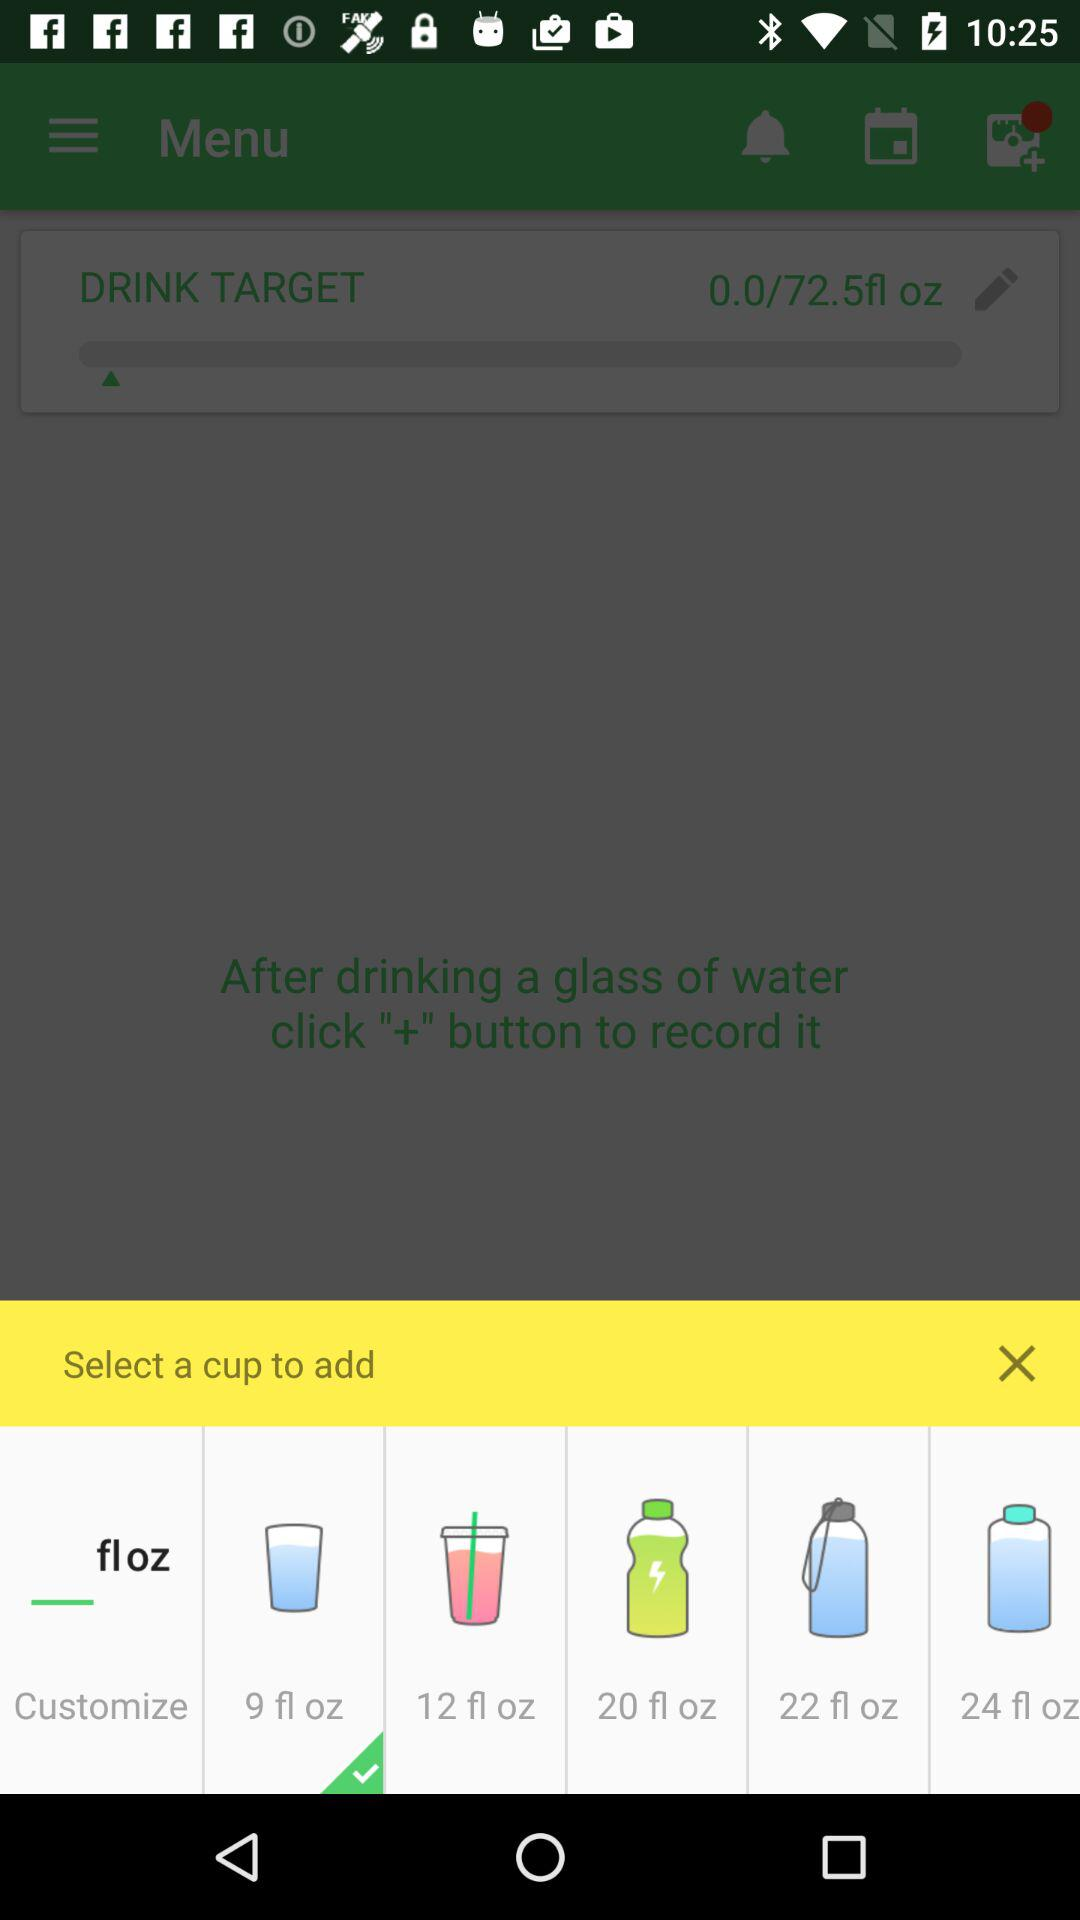Which cup is selected? The selected cup is "9 fl oz". 